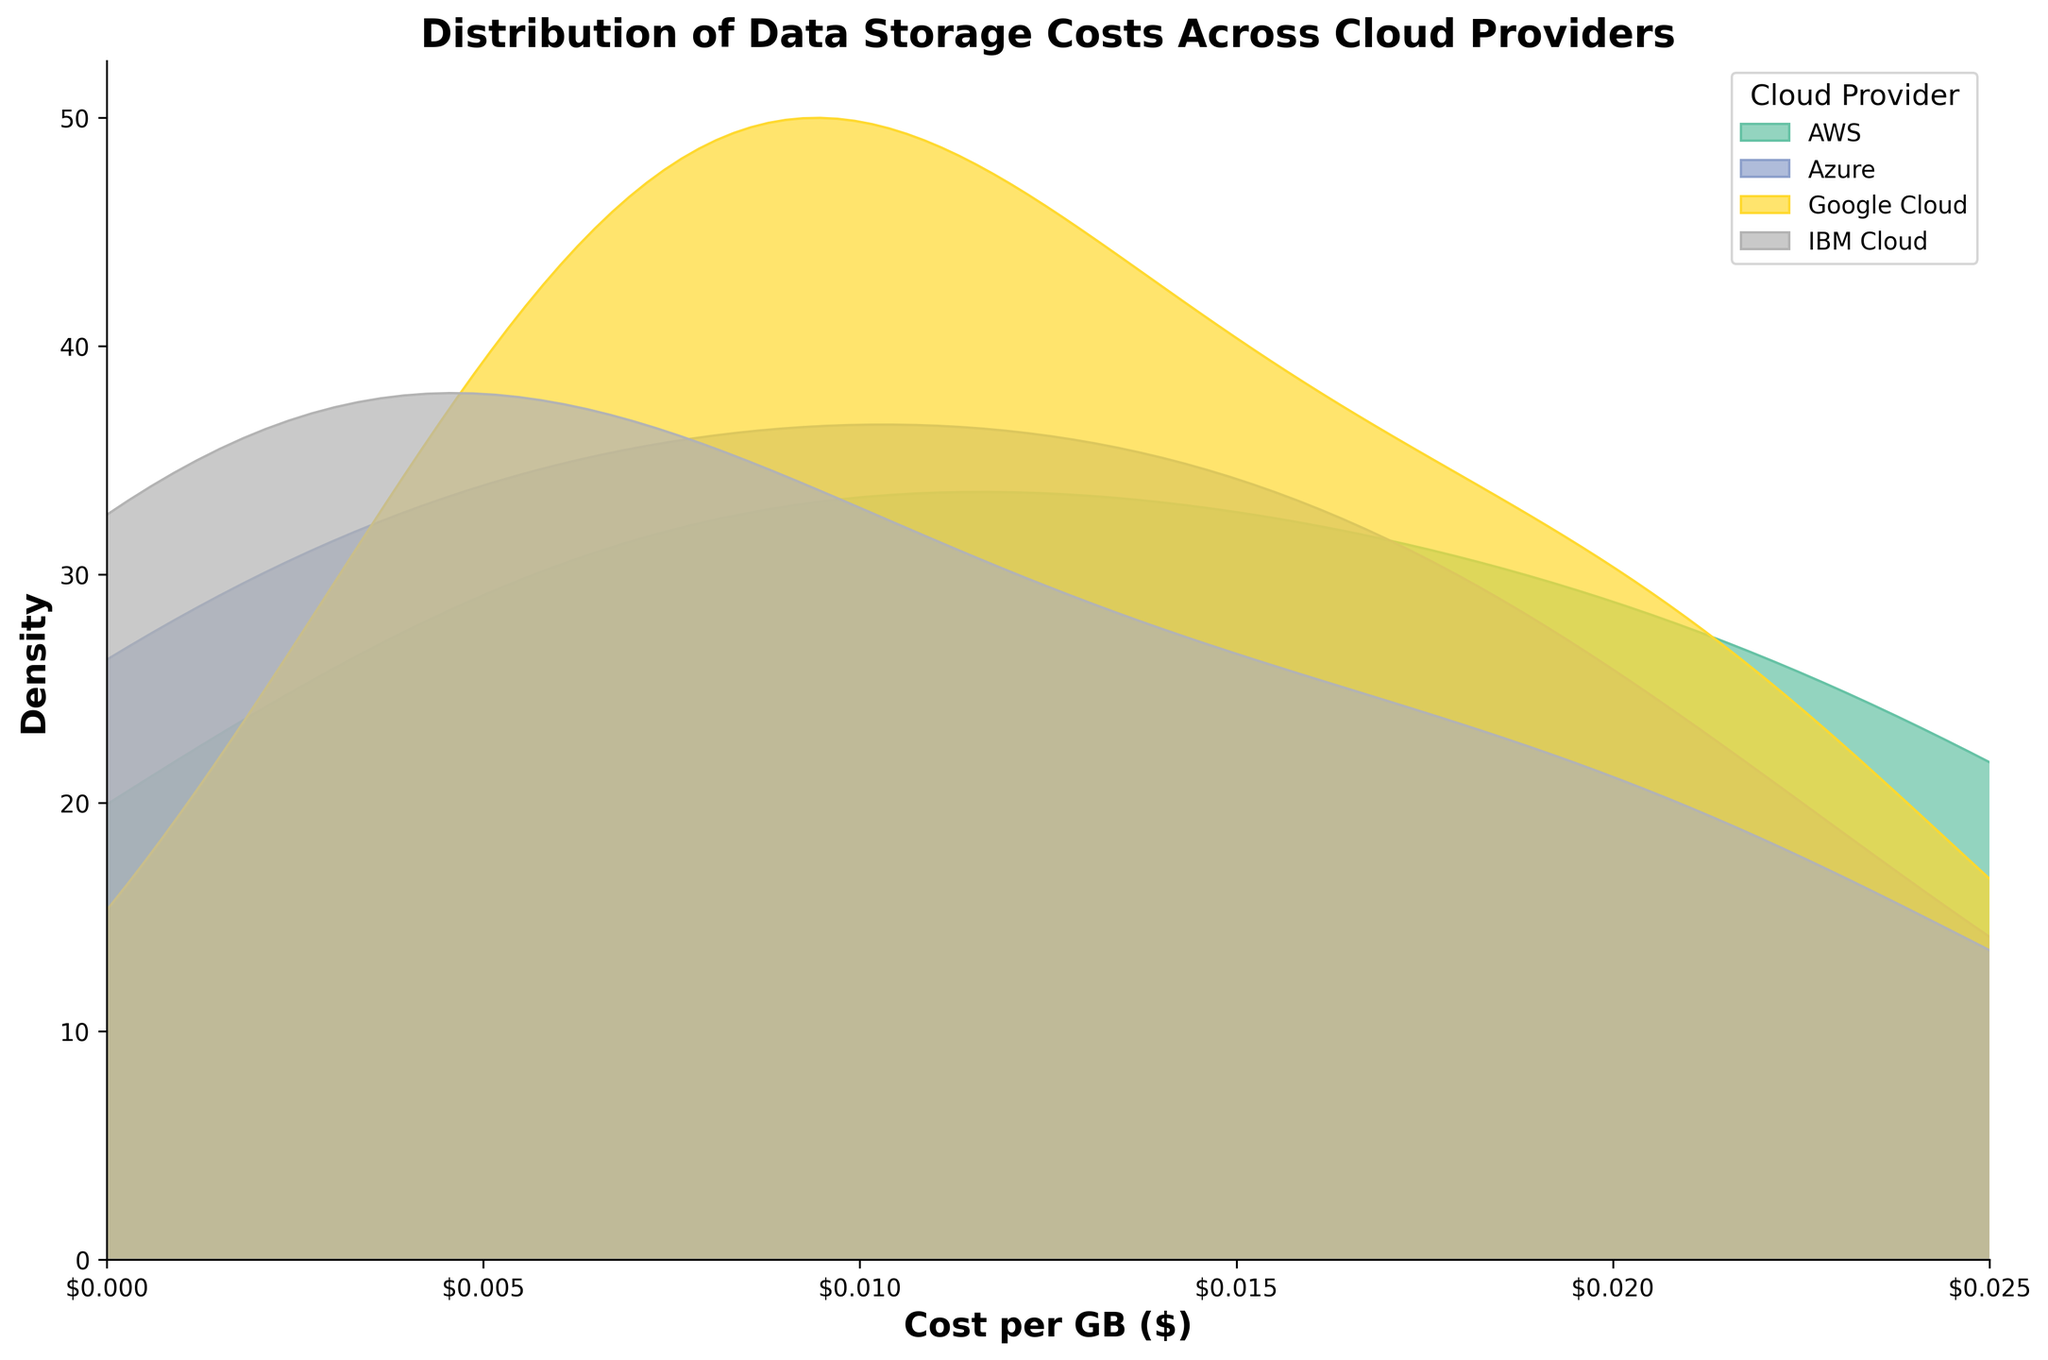What's the title of the plot? Look at the plot, the title is typically positioned at the top center of the figure.
Answer: Distribution of Data Storage Costs Across Cloud Providers What are the x and y axes labeled? Check the labels along the horizontal and vertical edges of the plot respectively.
Answer: The x-axis is labeled "Cost per GB ($)" and the y-axis is labeled "Density" Which cloud provider shows the highest density at the lowest cost per GB? Identify the provider whose density curve peaks closest to the leftmost part of the x-axis.
Answer: Azure What is the range of the x-axis? Look at the minimum and maximum values at the horizontal axis of the plot.
Answer: 0 to 0.025 Which two cloud providers appear to have the most overlap in their cost distributions? Look for the density curves that intersect or lie closely over each other significantly.
Answer: AWS and Google Cloud How many storage tiers are represented in the plot? Determine this by considering the different density curves for each cloud provider, each representing multiple tiers. This requires a logical step to recognize that each provider has multiple tiers without the explicit label in the plot.
Answer: Three for each provider Which provider has a tier with a cost per GB that is lower than anyone else's? Identify which provider's density curve peaks furthest to the left.
Answer: Azure Are all the density curves symmetrical? Examine the density curves to see if both sides from the peak are mirror images of each other.
Answer: No Which provider has the least variance in their cost distribution? Look for the flattest or most widespread density curve. Lower variance usually translates to a steep, narrow curve.
Answer: IBM Cloud Which cloud provider’s cost distribution curve has the widest spread? Observe the density curve that spans the largest portion of the x-axis.
Answer: Google Cloud 